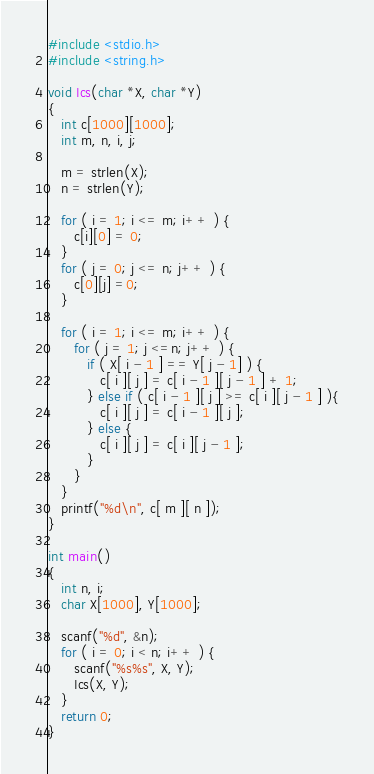Convert code to text. <code><loc_0><loc_0><loc_500><loc_500><_C_>#include <stdio.h>
#include <string.h>

void Ics(char *X, char *Y)
{
   int c[1000][1000];
   int m, n, i, j;

   m = strlen(X);
   n = strlen(Y);

   for ( i = 1; i <= m; i++ ) {
      c[i][0] = 0;
   }
   for ( j = 0; j <= n; j++ ) {
      c[0][j] =0;
   }

   for ( i = 1; i <= m; i++ ) {
      for ( j = 1; j <=n; j++ ) {
         if ( X[ i - 1 ] == Y[ j - 1] ) {
            c[ i ][ j ] = c[ i - 1 ][ j - 1 ] + 1;
         } else if ( c[ i - 1 ][ j ] >= c[ i ][ j - 1 ] ){
            c[ i ][ j ] = c[ i - 1 ][ j ];
         } else {
            c[ i ][ j ] = c[ i ][ j - 1 ];
         }
      }
   }
   printf("%d\n", c[ m ][ n ]);
}
     
int main()
{
   int n, i;
   char X[1000], Y[1000];

   scanf("%d", &n);
   for ( i = 0; i < n; i++ ) {
      scanf("%s%s", X, Y);
      Ics(X, Y);
   }
   return 0;
}</code> 